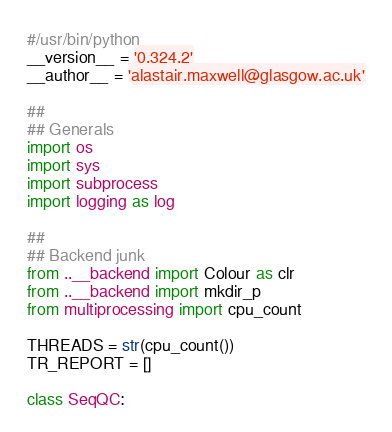<code> <loc_0><loc_0><loc_500><loc_500><_Python_>#/usr/bin/python
__version__ = '0.324.2'
__author__ = 'alastair.maxwell@glasgow.ac.uk'

##
## Generals
import os
import sys
import subprocess
import logging as log

##
## Backend junk
from ..__backend import Colour as clr
from ..__backend import mkdir_p
from multiprocessing import cpu_count

THREADS = str(cpu_count())
TR_REPORT = []

class SeqQC:
</code> 